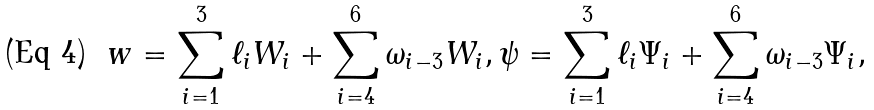Convert formula to latex. <formula><loc_0><loc_0><loc_500><loc_500>w = \sum _ { i = 1 } ^ { 3 } \ell _ { i } W _ { i } + \sum _ { i = 4 } ^ { 6 } \omega _ { i - 3 } W _ { i } , \psi = \sum _ { i = 1 } ^ { 3 } \ell _ { i } \Psi _ { i } + \sum _ { i = 4 } ^ { 6 } \omega _ { i - 3 } \Psi _ { i } ,</formula> 